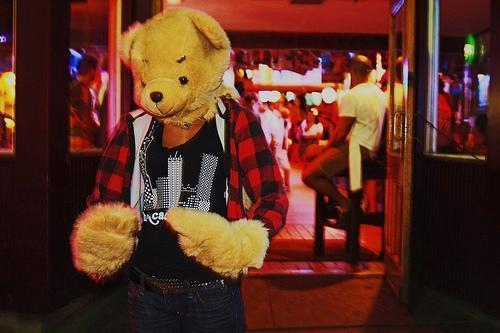How many teddy bears are brown?
Give a very brief answer. 1. How many pink bears in picture?
Give a very brief answer. 0. How many bears are there?
Give a very brief answer. 1. How many bears are facing the camera?
Give a very brief answer. 1. How many people are there?
Give a very brief answer. 2. How many blue cars are there?
Give a very brief answer. 0. 